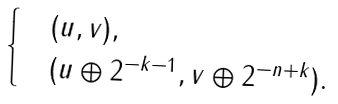<formula> <loc_0><loc_0><loc_500><loc_500>\begin{cases} & ( u , v ) , \\ & ( u \oplus 2 ^ { - k - 1 } , v \oplus 2 ^ { - n + k } ) . \end{cases}</formula> 